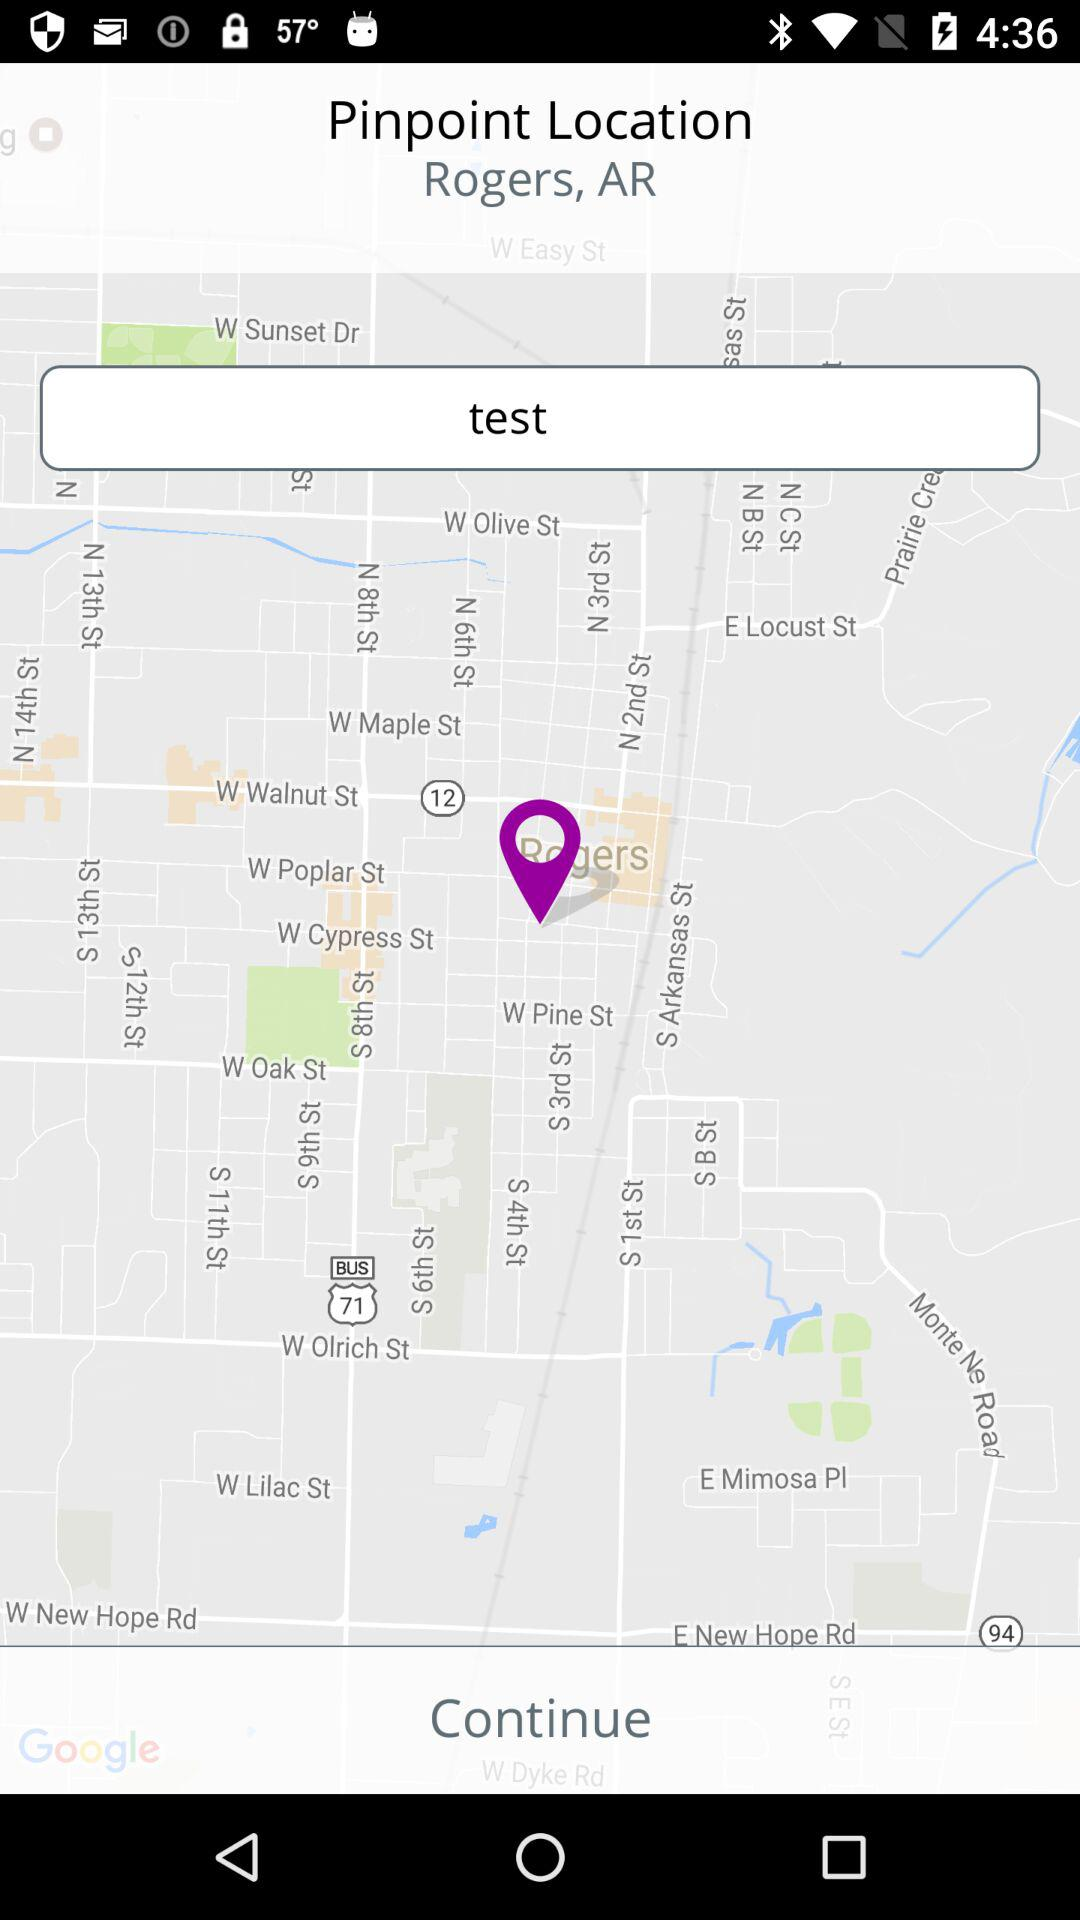What is the pinpoint location given on the screen? The pinpoint location given on the screen is Rogers, AR. 